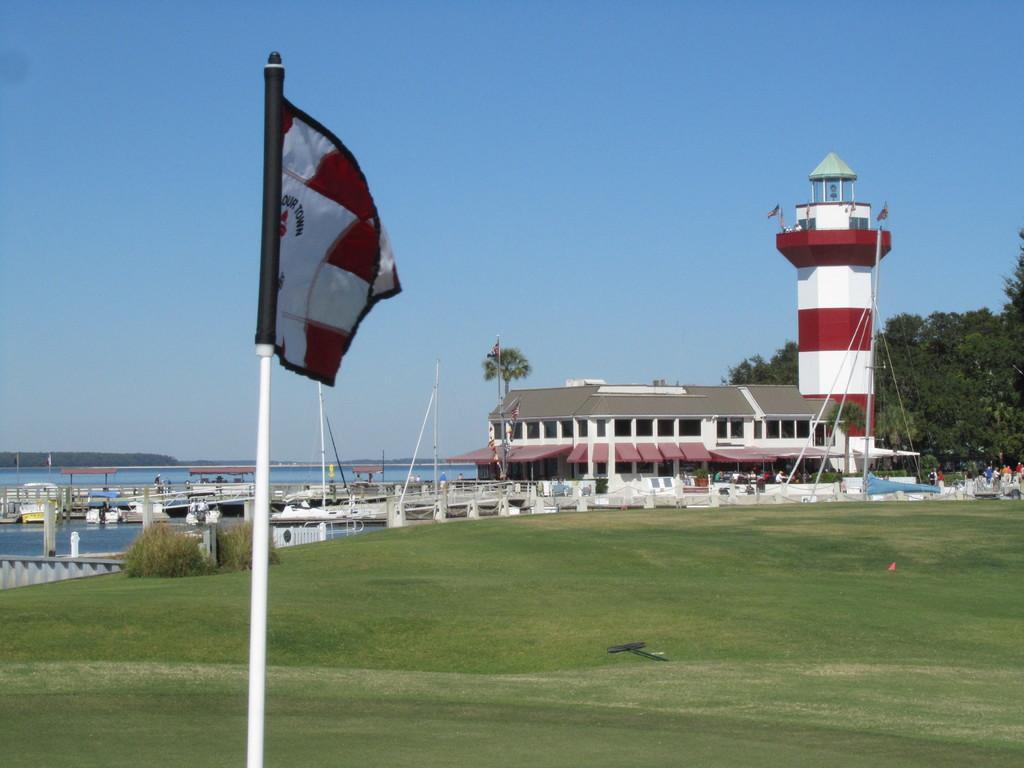Could you give a brief overview of what you see in this image? In this picture there is harbour town in the image and there is a flag on the left side of the image and there are trees on the right side of the image. 